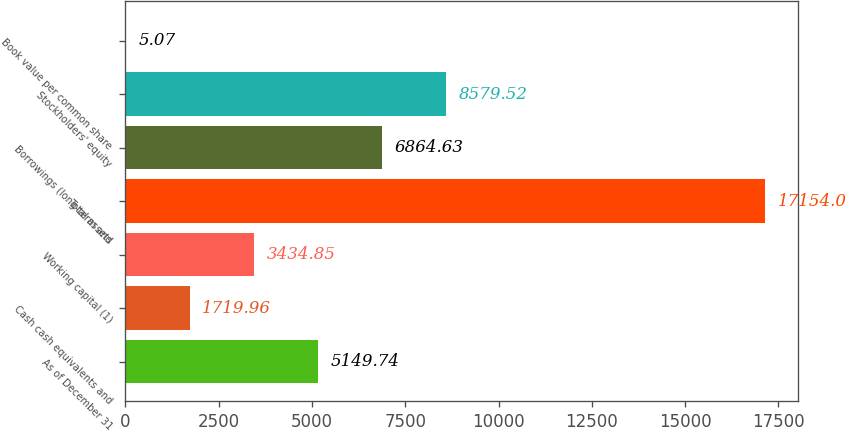<chart> <loc_0><loc_0><loc_500><loc_500><bar_chart><fcel>As of December 31<fcel>Cash cash equivalents and<fcel>Working capital (1)<fcel>Total assets<fcel>Borrowings (long-term and<fcel>Stockholders' equity<fcel>Book value per common share<nl><fcel>5149.74<fcel>1719.96<fcel>3434.85<fcel>17154<fcel>6864.63<fcel>8579.52<fcel>5.07<nl></chart> 